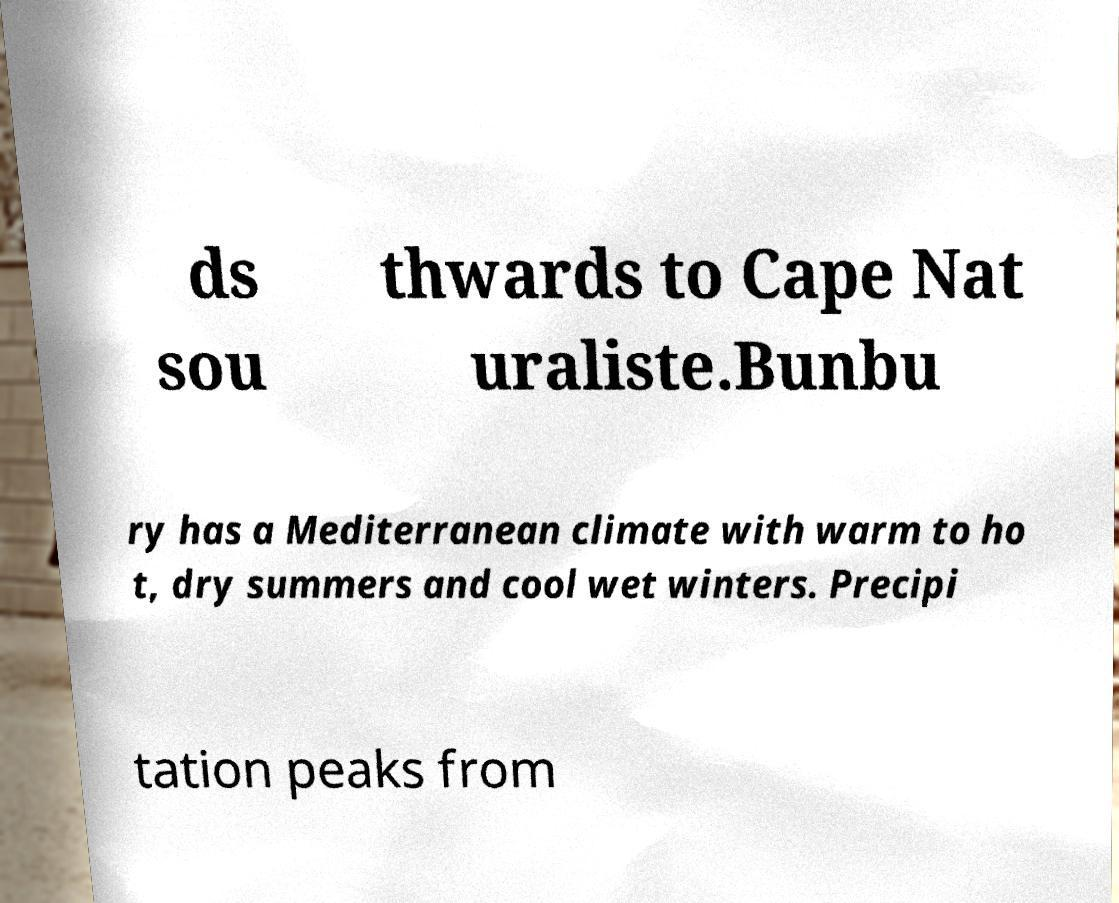Please read and relay the text visible in this image. What does it say? ds sou thwards to Cape Nat uraliste.Bunbu ry has a Mediterranean climate with warm to ho t, dry summers and cool wet winters. Precipi tation peaks from 